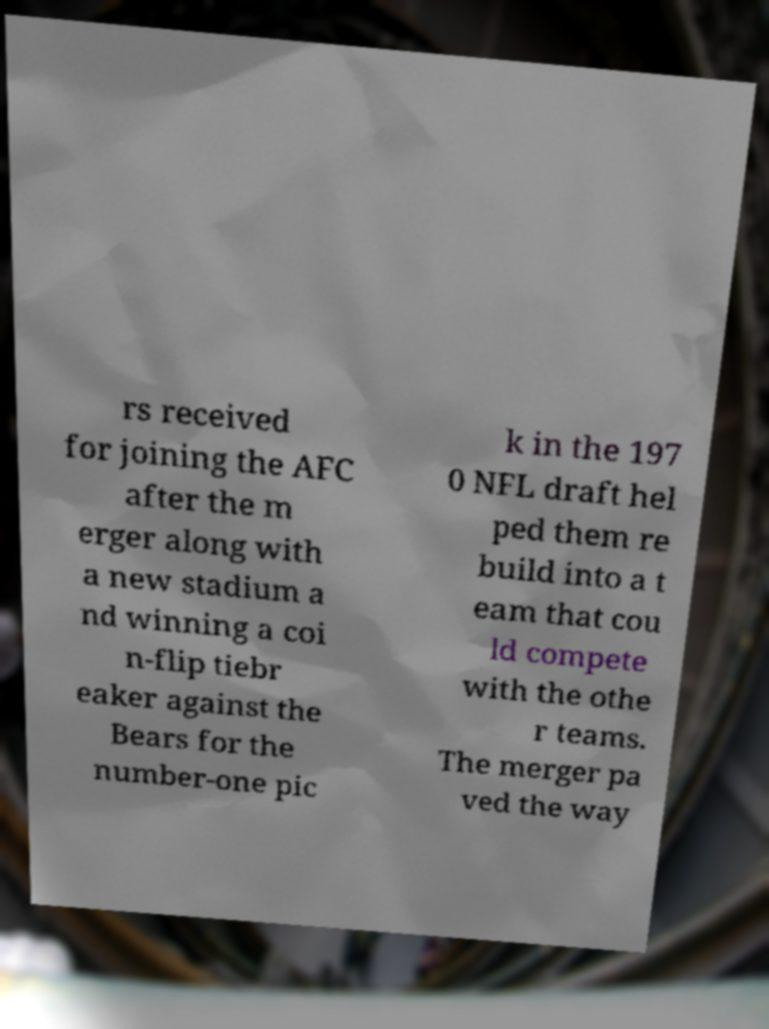What messages or text are displayed in this image? I need them in a readable, typed format. rs received for joining the AFC after the m erger along with a new stadium a nd winning a coi n-flip tiebr eaker against the Bears for the number-one pic k in the 197 0 NFL draft hel ped them re build into a t eam that cou ld compete with the othe r teams. The merger pa ved the way 